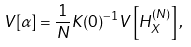Convert formula to latex. <formula><loc_0><loc_0><loc_500><loc_500>V [ \alpha ] = \frac { 1 } { N } K ( 0 ) ^ { - 1 } V \left [ H ^ { ( N ) } _ { X } \right ] ,</formula> 